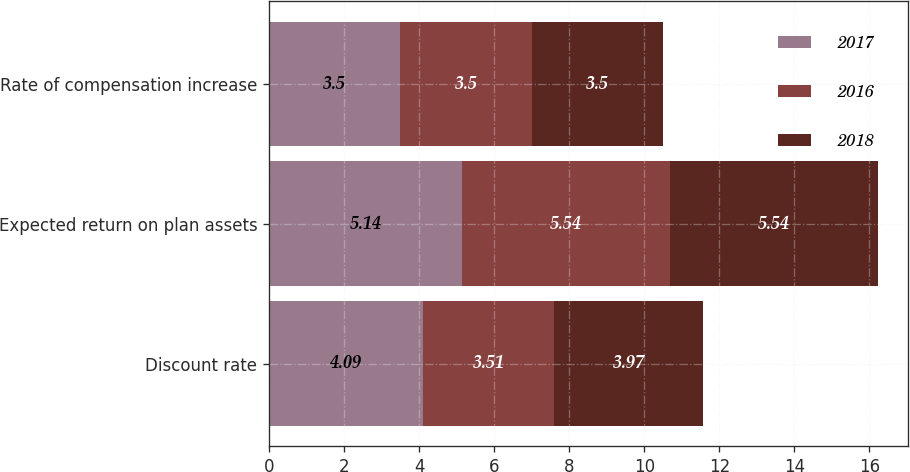Convert chart to OTSL. <chart><loc_0><loc_0><loc_500><loc_500><stacked_bar_chart><ecel><fcel>Discount rate<fcel>Expected return on plan assets<fcel>Rate of compensation increase<nl><fcel>2017<fcel>4.09<fcel>5.14<fcel>3.5<nl><fcel>2016<fcel>3.51<fcel>5.54<fcel>3.5<nl><fcel>2018<fcel>3.97<fcel>5.54<fcel>3.5<nl></chart> 